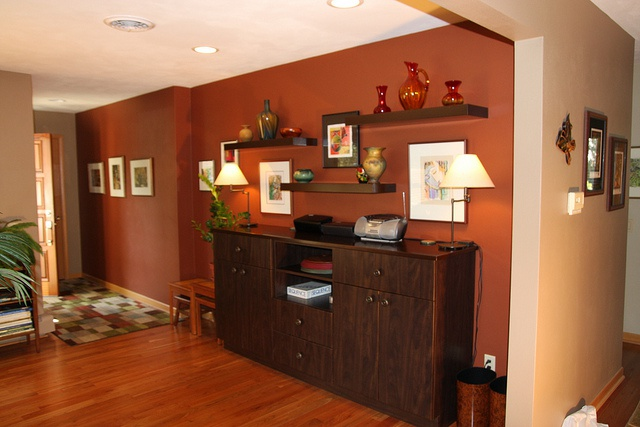Describe the objects in this image and their specific colors. I can see chair in tan, maroon, black, and brown tones, potted plant in tan, darkgreen, black, and gray tones, potted plant in tan, olive, maroon, and black tones, vase in tan, maroon, brown, and red tones, and book in tan, gray, and olive tones in this image. 